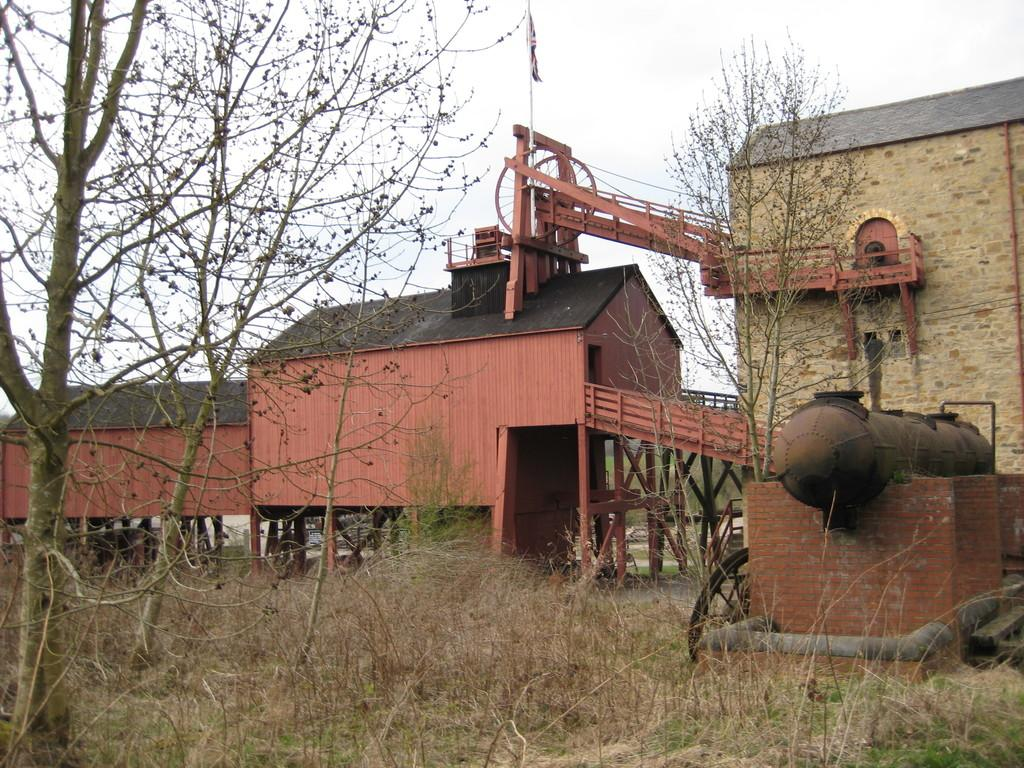What type of structures can be seen in the image? There are houses in the image. What is located in the foreground of the image? There is an unspecified object in the foreground. What type of vegetation is present around the houses? There is a lot of grass around the houses. What type of trees are present around the houses? Dry trees are present around the houses. What type of adjustment can be seen on the property in the image? There is no specific adjustment mentioned or visible in the image. 